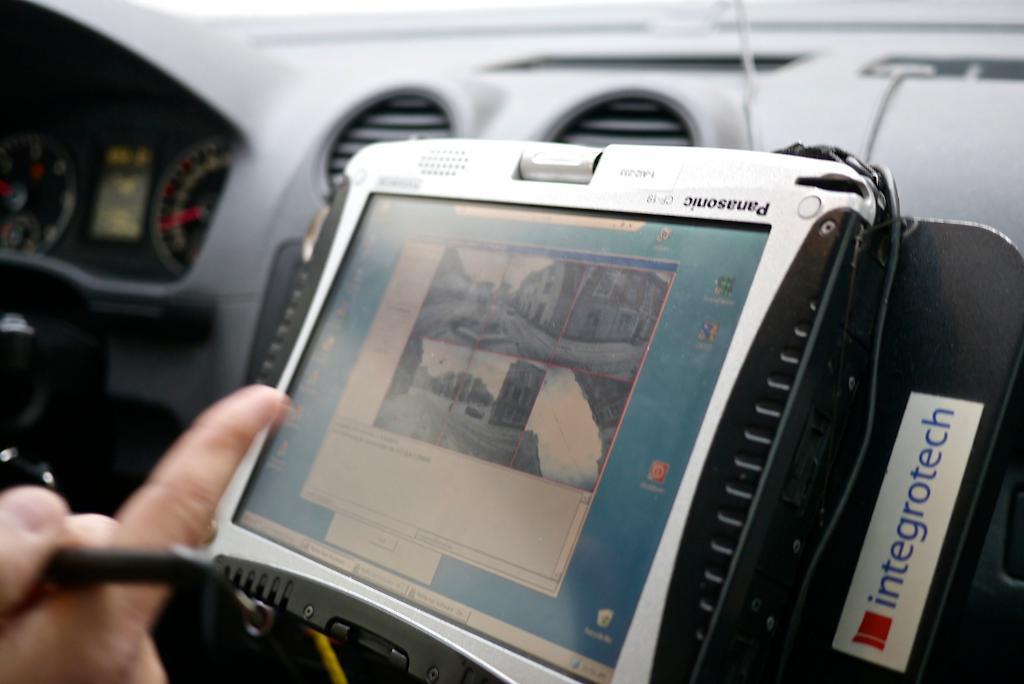Describe this image in one or two sentences. In this image, we can see a cockpit. There is a person hand in the bottom left of the image. There is a gadget in the middle of the image. 